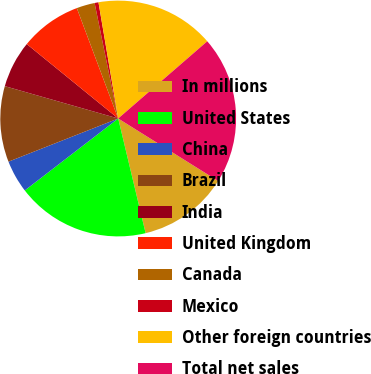Convert chart. <chart><loc_0><loc_0><loc_500><loc_500><pie_chart><fcel>In millions<fcel>United States<fcel>China<fcel>Brazil<fcel>India<fcel>United Kingdom<fcel>Canada<fcel>Mexico<fcel>Other foreign countries<fcel>Total net sales<nl><fcel>12.37%<fcel>18.29%<fcel>4.48%<fcel>10.39%<fcel>6.45%<fcel>8.42%<fcel>2.5%<fcel>0.53%<fcel>16.31%<fcel>20.26%<nl></chart> 